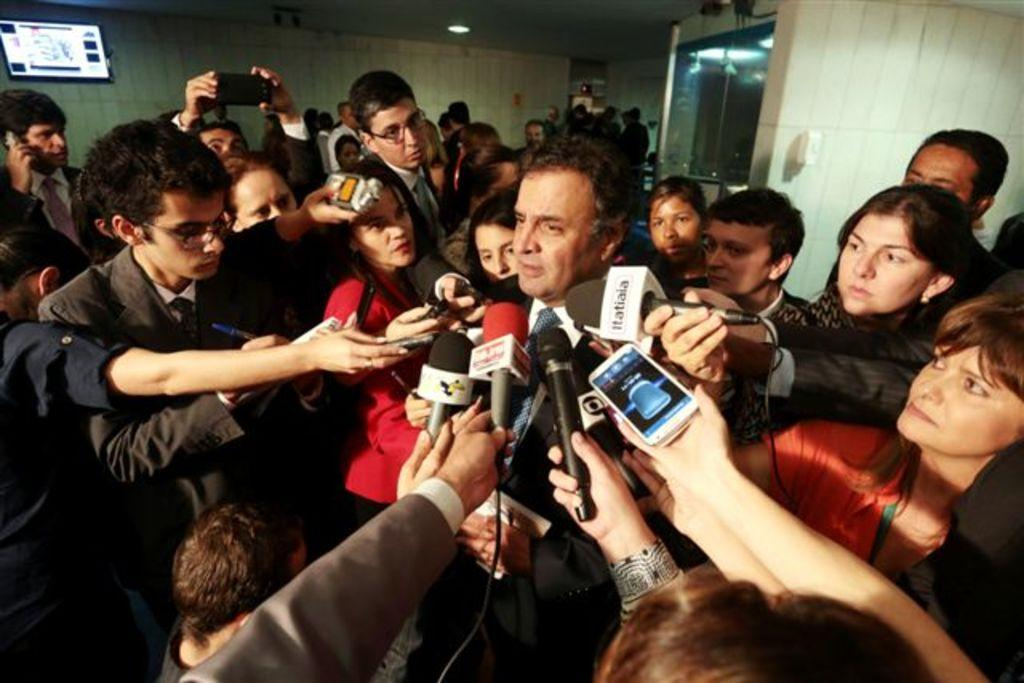How many people are in the image? There are people in the image, but the exact number is not specified. What are the people doing in the image? The people are standing and holding microphones. What can be seen in the background of the image? There is a wall and a screen in the background of the image. What type of division can be seen between the people in the image? There is no division visible between the people in the image; they are standing together. What taste is associated with the microphones in the image? Microphones do not have a taste, as they are not edible objects. 